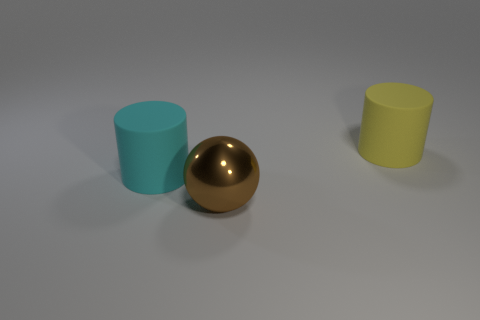There is a object that is behind the big ball and right of the cyan thing; what is its shape?
Ensure brevity in your answer.  Cylinder. Is there any other thing that is the same size as the cyan cylinder?
Your response must be concise. Yes. There is a cyan cylinder that is the same material as the yellow cylinder; what is its size?
Offer a very short reply. Large. What number of things are either rubber objects that are on the right side of the brown shiny ball or big cylinders that are behind the cyan cylinder?
Ensure brevity in your answer.  1. Is the size of the matte cylinder that is to the left of the brown sphere the same as the metal thing?
Make the answer very short. Yes. The large rubber object that is in front of the yellow cylinder is what color?
Provide a short and direct response. Cyan. There is another large rubber thing that is the same shape as the yellow rubber object; what is its color?
Keep it short and to the point. Cyan. How many big cylinders are on the right side of the big cylinder in front of the thing to the right of the brown sphere?
Your response must be concise. 1. Is there any other thing that is the same material as the large yellow thing?
Keep it short and to the point. Yes. Are there fewer cyan things in front of the big sphere than large yellow cylinders?
Ensure brevity in your answer.  Yes. 